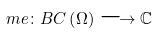Convert formula to latex. <formula><loc_0><loc_0><loc_500><loc_500>\ m e \colon B C \left ( \Omega \right ) \longrightarrow \mathbb { C }</formula> 